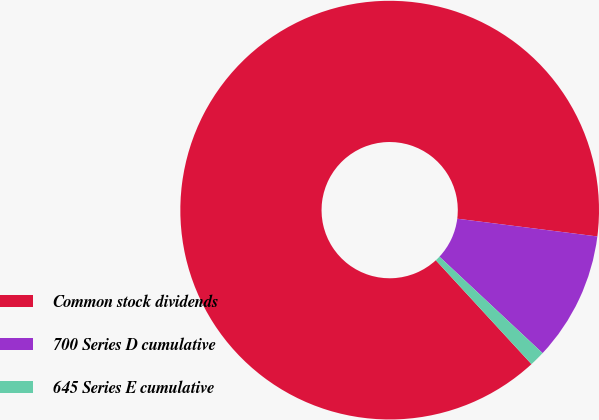<chart> <loc_0><loc_0><loc_500><loc_500><pie_chart><fcel>Common stock dividends<fcel>700 Series D cumulative<fcel>645 Series E cumulative<nl><fcel>88.85%<fcel>9.96%<fcel>1.19%<nl></chart> 